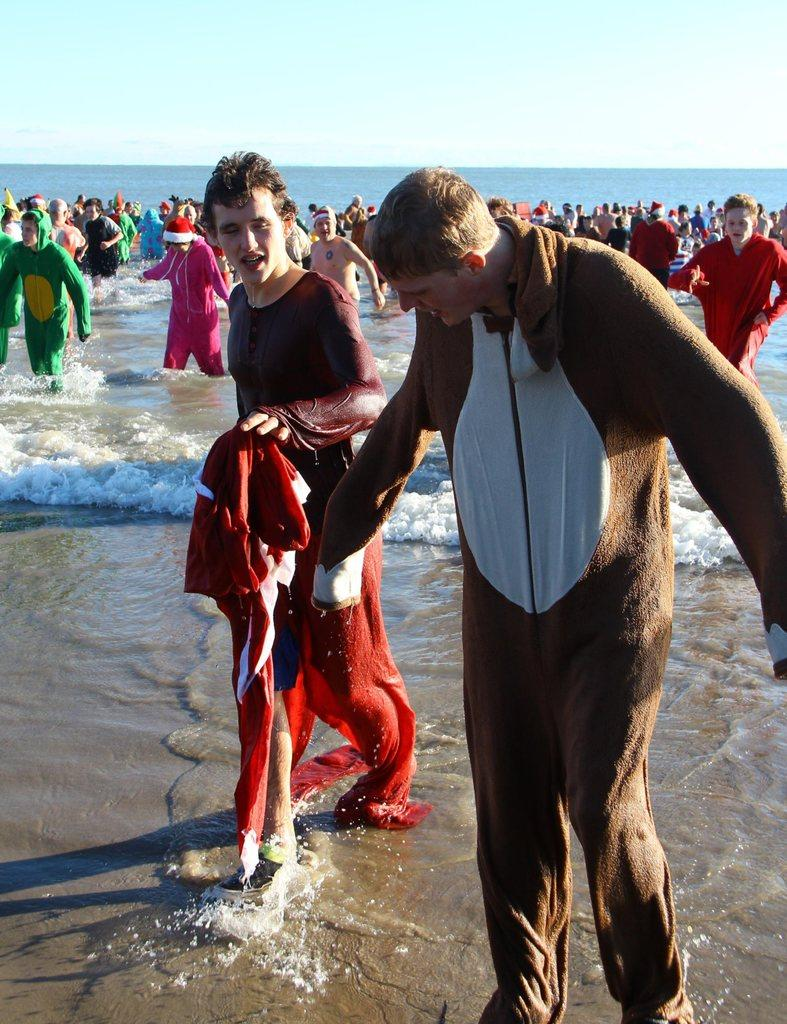What is the main subject of the image? The main subject of the image is a group of people. How are the people dressed in the image? The people are wearing different color dresses in the image. Where are the people located in the image? The people are in the water in the image. What can be seen in the background of the image? The sky is visible in the background of the image. What type of government is depicted in the image? There is no depiction of a government in the image; it features a group of people in the water. Can you tell me how many ducks are swimming with the people in the image? There are no ducks present in the image; it features a group of people in the water. 